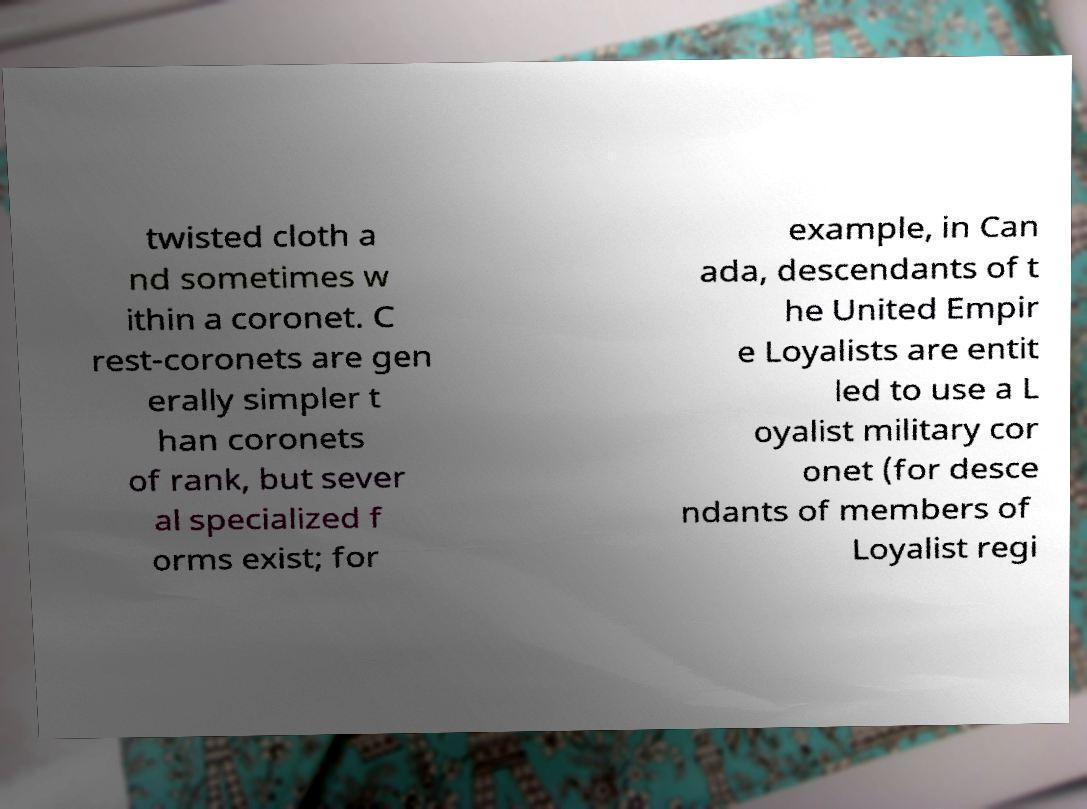Can you accurately transcribe the text from the provided image for me? twisted cloth a nd sometimes w ithin a coronet. C rest-coronets are gen erally simpler t han coronets of rank, but sever al specialized f orms exist; for example, in Can ada, descendants of t he United Empir e Loyalists are entit led to use a L oyalist military cor onet (for desce ndants of members of Loyalist regi 